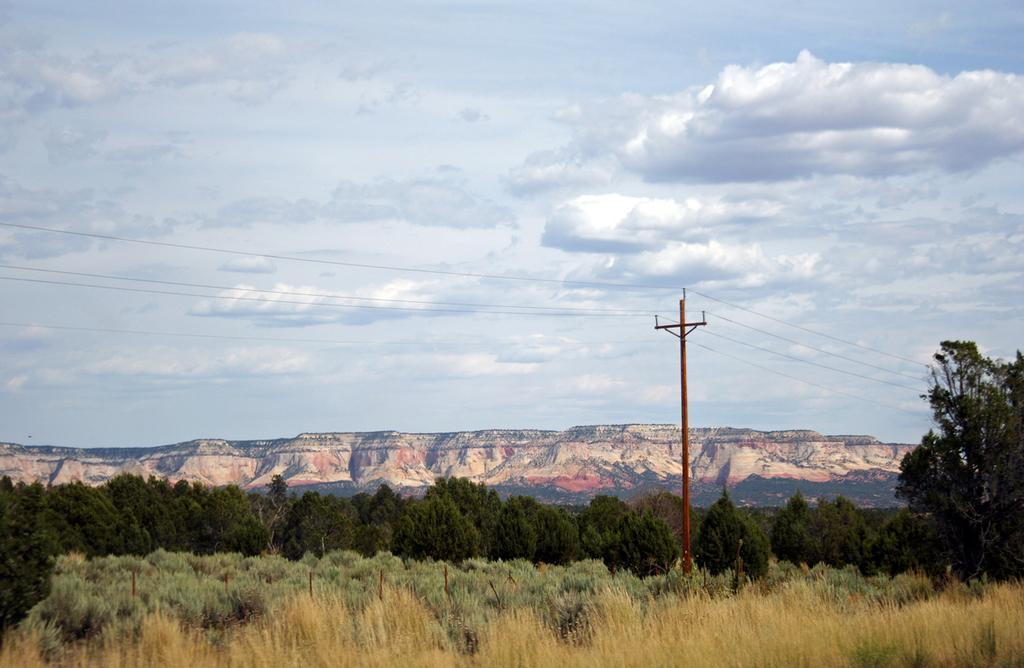How would you summarize this image in a sentence or two? In this image, I can see the trees with branches and leaves. This is the current pole with the current wires. I can see the hills. These are the clouds in the sky. At the bottom of the image, I think this is the dried grass. 